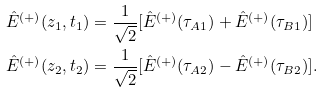Convert formula to latex. <formula><loc_0><loc_0><loc_500><loc_500>\hat { E } ^ { ( + ) } ( z _ { 1 } , t _ { 1 } ) & = \frac { 1 } { \sqrt { 2 } } [ \hat { E } ^ { ( + ) } ( \tau _ { A 1 } ) + \hat { E } ^ { ( + ) } ( \tau _ { B 1 } ) ] \\ \hat { E } ^ { ( + ) } ( z _ { 2 } , t _ { 2 } ) & = \frac { 1 } { \sqrt { 2 } } [ \hat { E } ^ { ( + ) } ( \tau _ { A 2 } ) - \hat { E } ^ { ( + ) } ( \tau _ { B 2 } ) ] .</formula> 